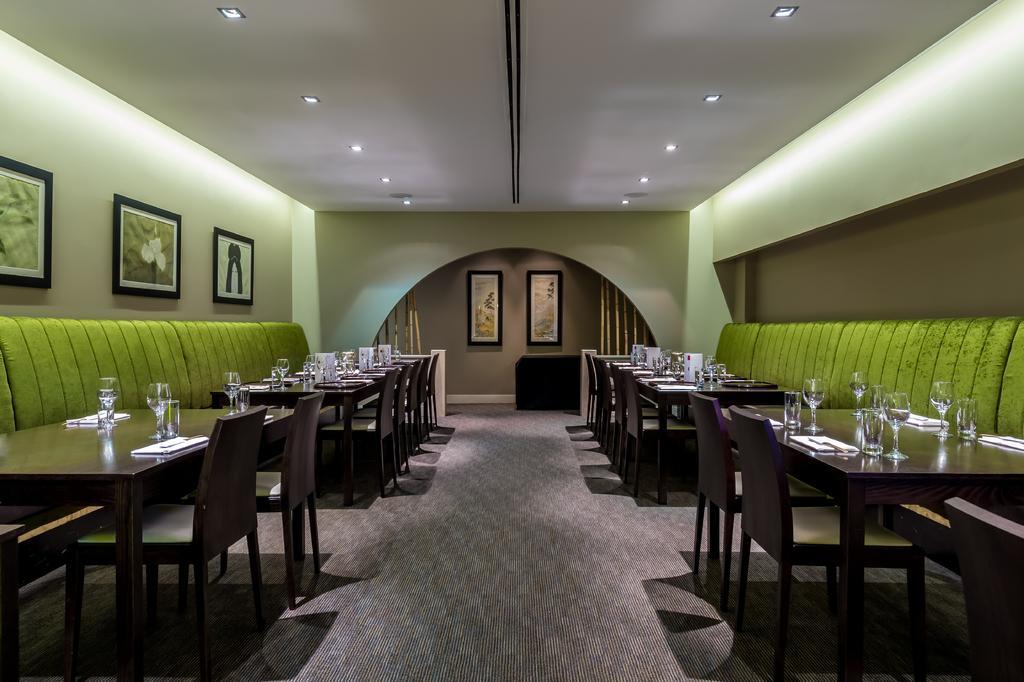Could you give a brief overview of what you see in this image? In this image there are couches, chairs, tables, pictures, ceiling lights and objects. Pictures are on the walls. On the tables there are glasses and objects. Floor with carpet. 